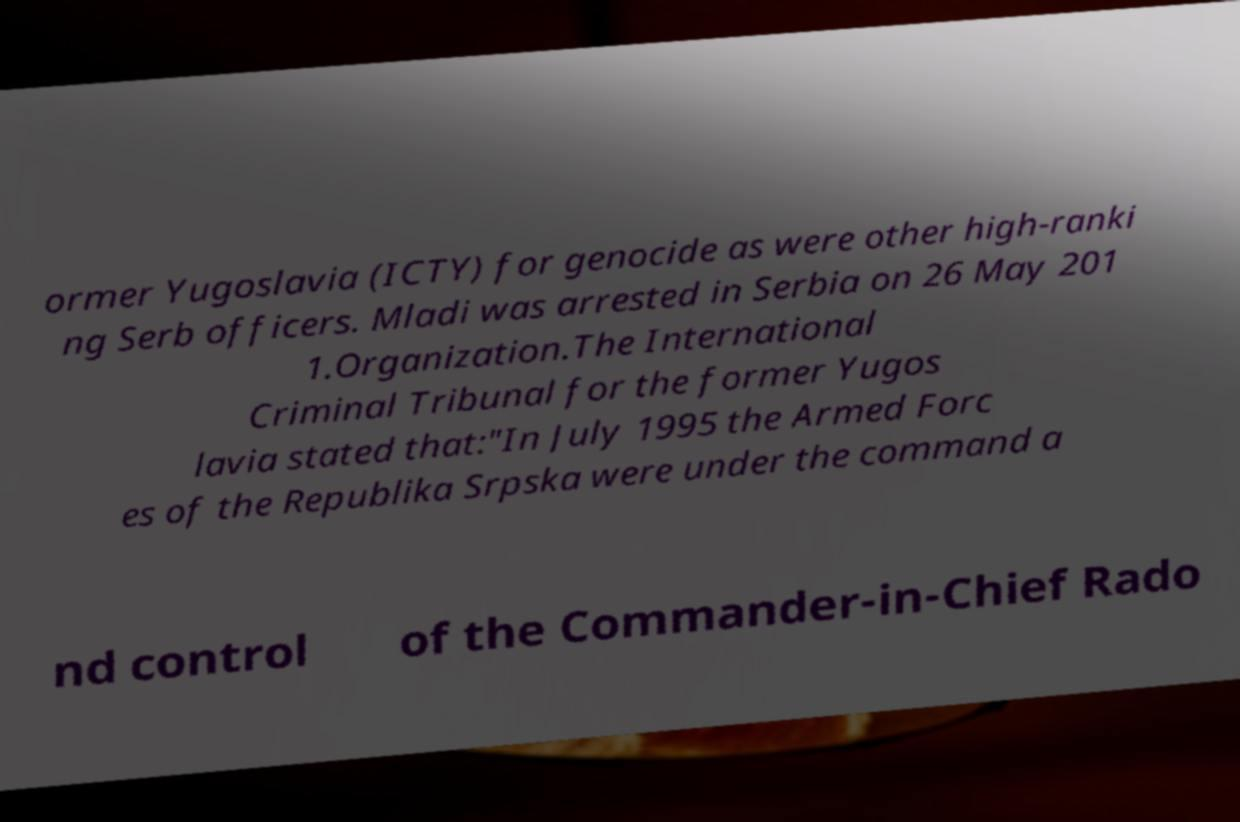Please read and relay the text visible in this image. What does it say? ormer Yugoslavia (ICTY) for genocide as were other high-ranki ng Serb officers. Mladi was arrested in Serbia on 26 May 201 1.Organization.The International Criminal Tribunal for the former Yugos lavia stated that:"In July 1995 the Armed Forc es of the Republika Srpska were under the command a nd control of the Commander-in-Chief Rado 